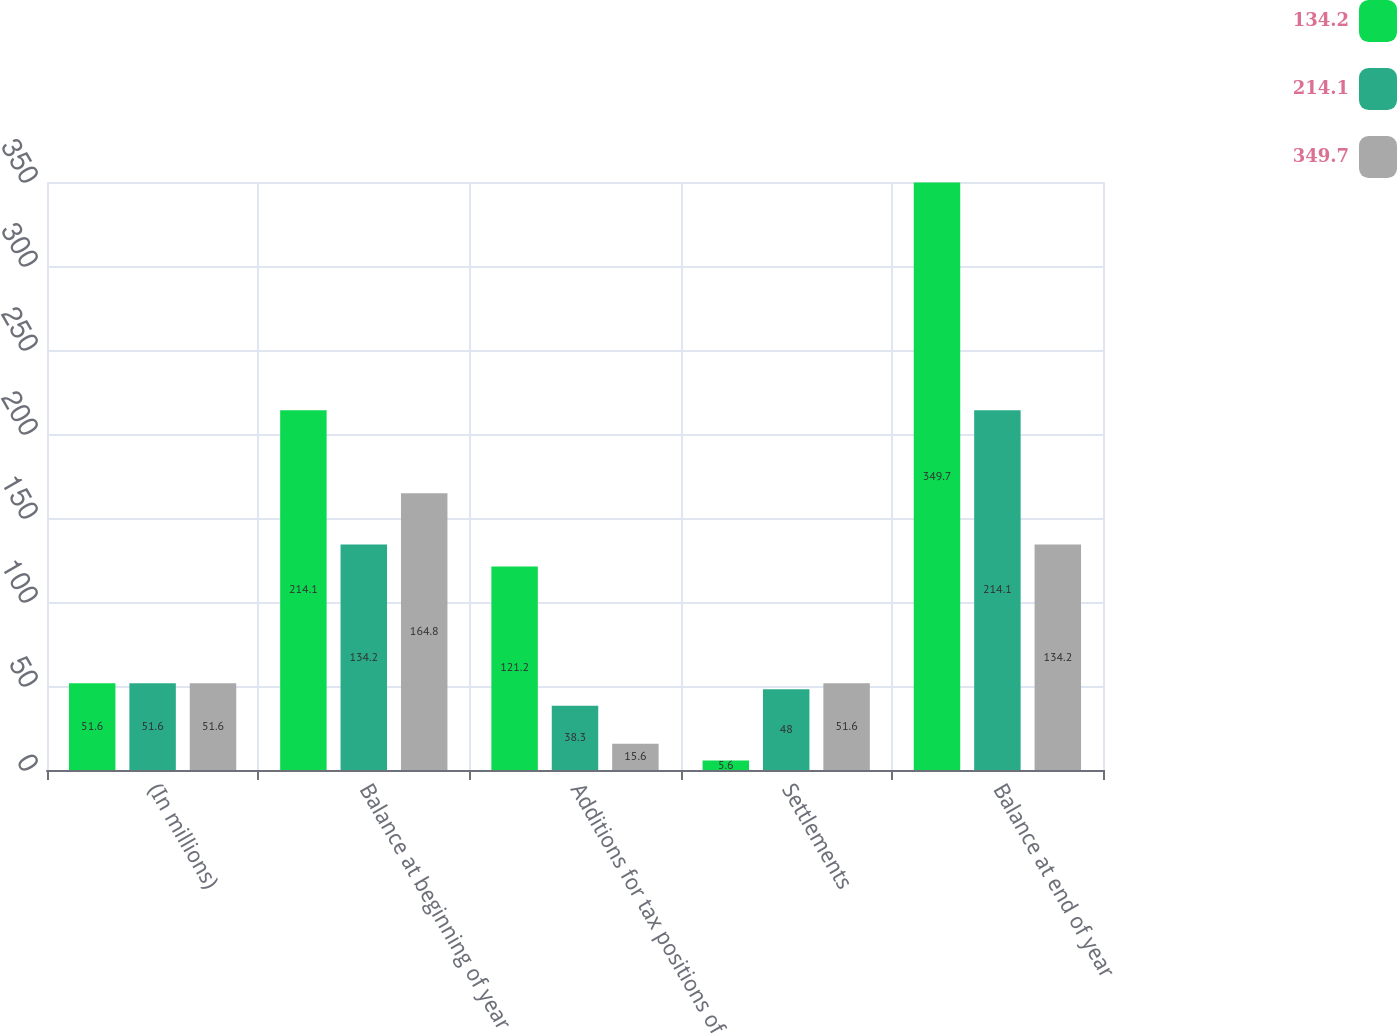<chart> <loc_0><loc_0><loc_500><loc_500><stacked_bar_chart><ecel><fcel>(In millions)<fcel>Balance at beginning of year<fcel>Additions for tax positions of<fcel>Settlements<fcel>Balance at end of year<nl><fcel>134.2<fcel>51.6<fcel>214.1<fcel>121.2<fcel>5.6<fcel>349.7<nl><fcel>214.1<fcel>51.6<fcel>134.2<fcel>38.3<fcel>48<fcel>214.1<nl><fcel>349.7<fcel>51.6<fcel>164.8<fcel>15.6<fcel>51.6<fcel>134.2<nl></chart> 